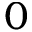<formula> <loc_0><loc_0><loc_500><loc_500>0</formula> 